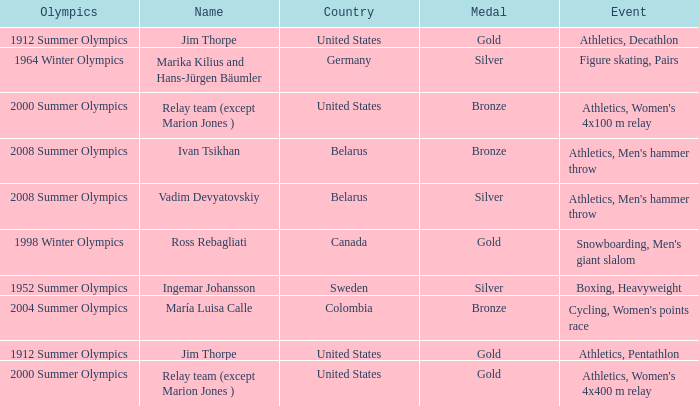Would you be able to parse every entry in this table? {'header': ['Olympics', 'Name', 'Country', 'Medal', 'Event'], 'rows': [['1912 Summer Olympics', 'Jim Thorpe', 'United States', 'Gold', 'Athletics, Decathlon'], ['1964 Winter Olympics', 'Marika Kilius and Hans-Jürgen Bäumler', 'Germany', 'Silver', 'Figure skating, Pairs'], ['2000 Summer Olympics', 'Relay team (except Marion Jones )', 'United States', 'Bronze', "Athletics, Women's 4x100 m relay"], ['2008 Summer Olympics', 'Ivan Tsikhan', 'Belarus', 'Bronze', "Athletics, Men's hammer throw"], ['2008 Summer Olympics', 'Vadim Devyatovskiy', 'Belarus', 'Silver', "Athletics, Men's hammer throw"], ['1998 Winter Olympics', 'Ross Rebagliati', 'Canada', 'Gold', "Snowboarding, Men's giant slalom"], ['1952 Summer Olympics', 'Ingemar Johansson', 'Sweden', 'Silver', 'Boxing, Heavyweight'], ['2004 Summer Olympics', 'María Luisa Calle', 'Colombia', 'Bronze', "Cycling, Women's points race"], ['1912 Summer Olympics', 'Jim Thorpe', 'United States', 'Gold', 'Athletics, Pentathlon'], ['2000 Summer Olympics', 'Relay team (except Marion Jones )', 'United States', 'Gold', "Athletics, Women's 4x400 m relay"]]} Which event is in the 1952 summer olympics? Boxing, Heavyweight. 